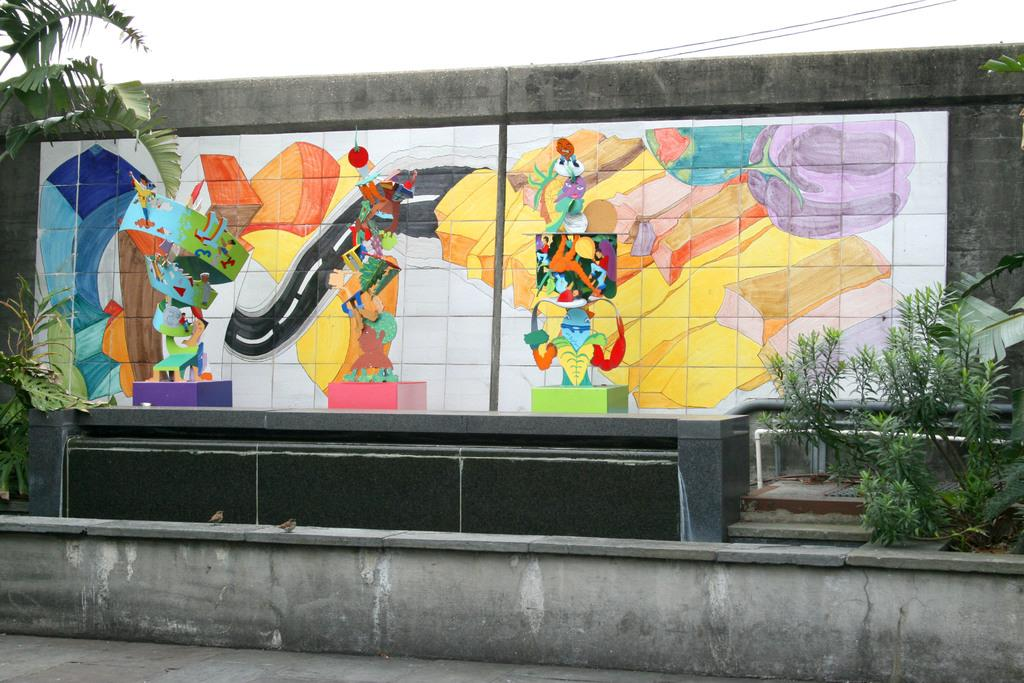What type of artwork is on the wall in the image? There is a painting of cartoons on the wall in the image. What type of toys are visible in the image? There are blocks visible in the image. What type of natural elements are present in the image? There are trees and plants in the image. What type of infrastructure is present in the image? There are wires and a road at the bottom of the image. What type of bread is being used to build the blocks in the image? There is no bread present in the image; the blocks are not made of bread. 